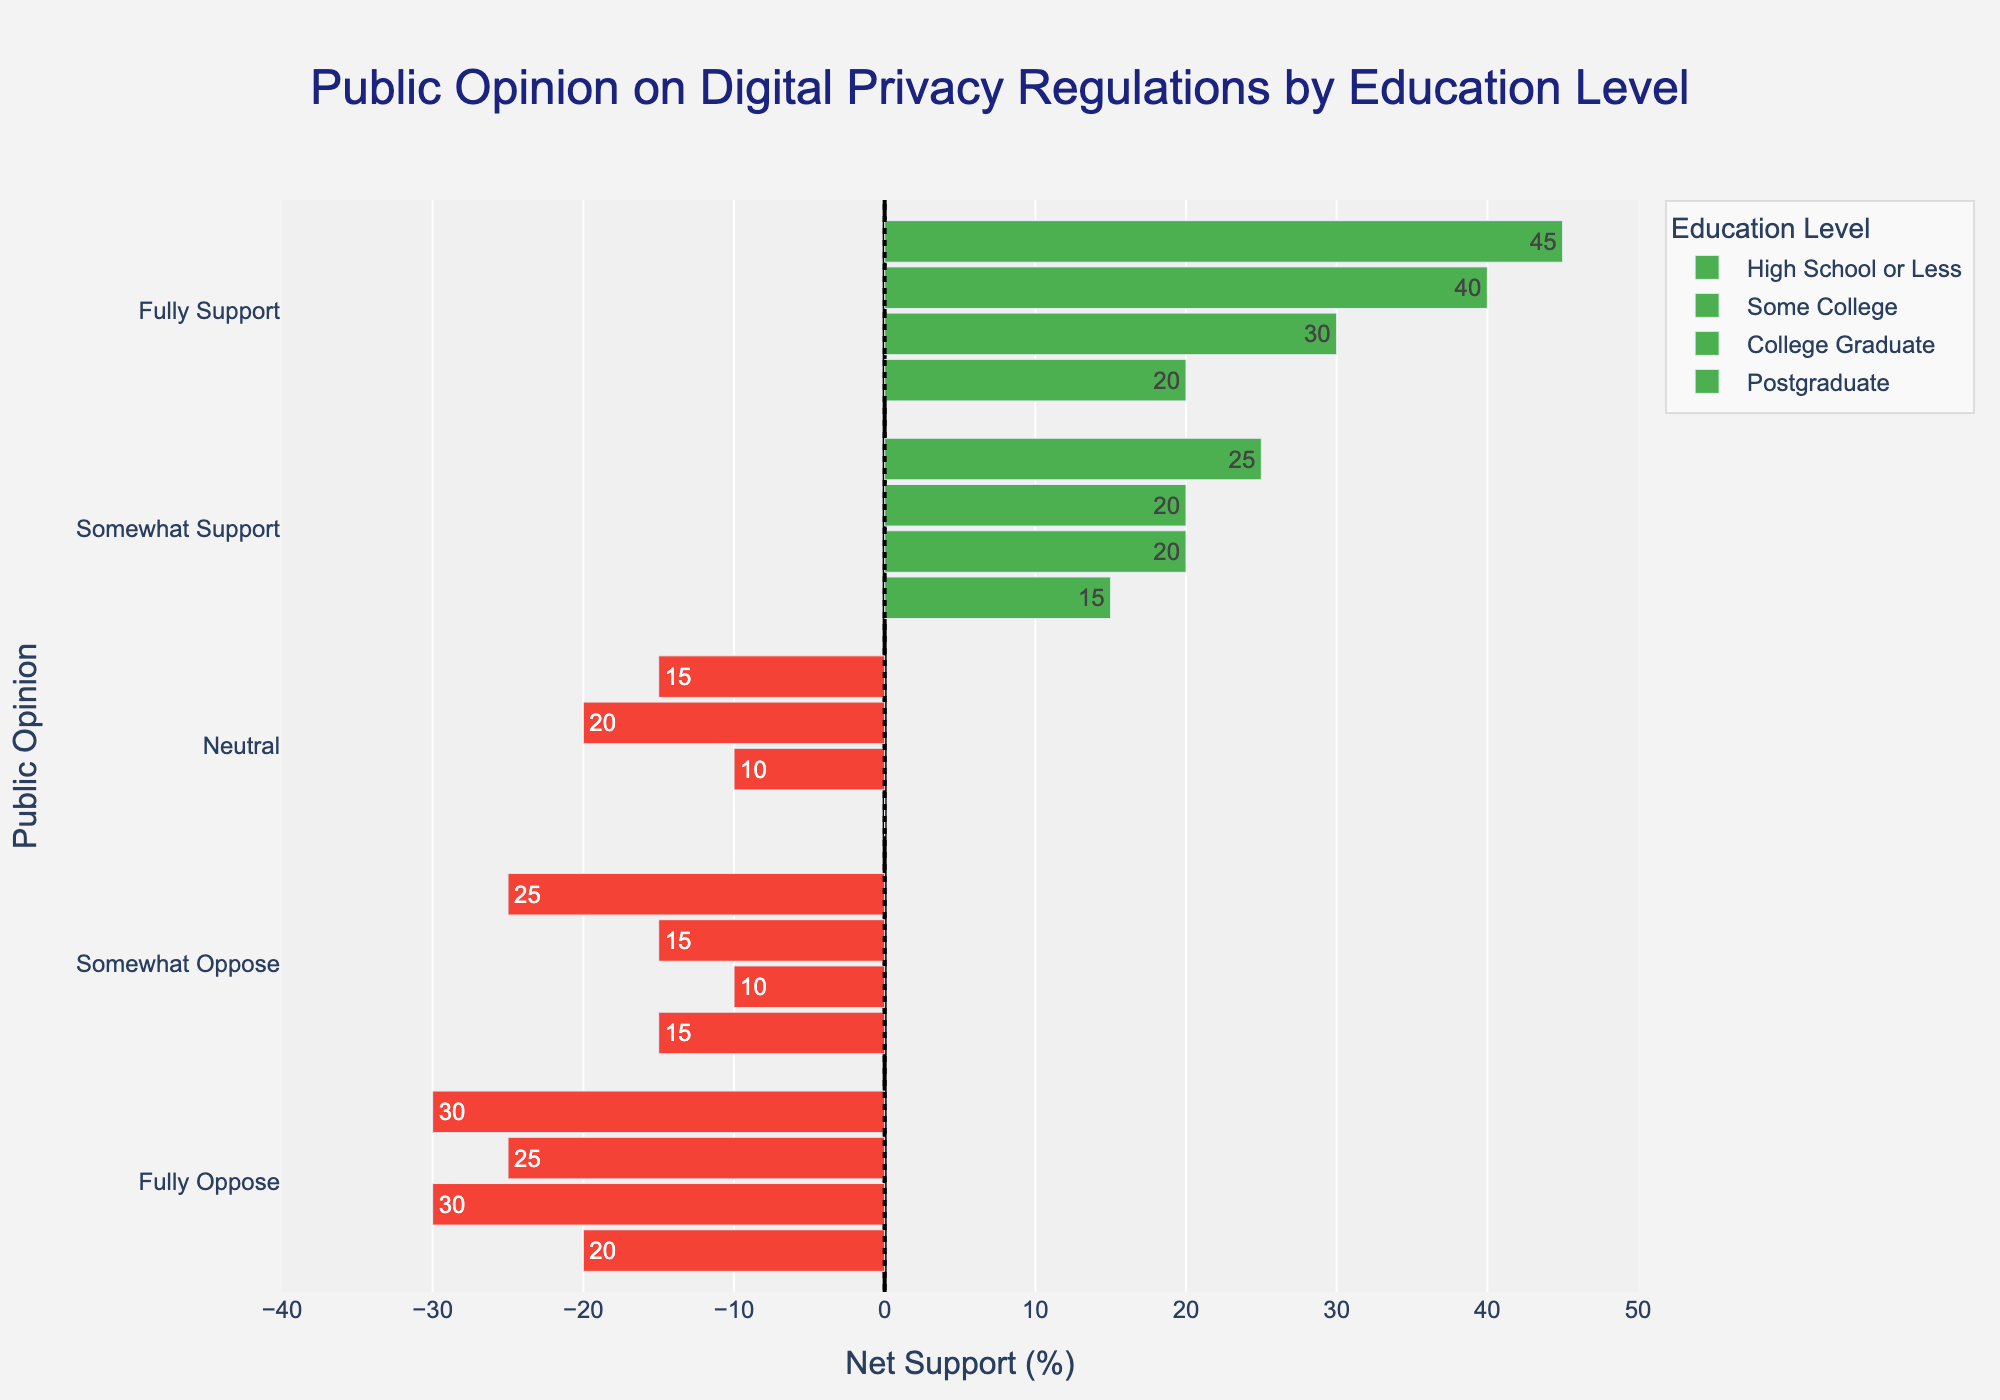What's the education level with the highest net support for fully supporting digital privacy regulations? Look for the bar with the highest positive net support in the 'Fully Support' category. The 'Postgraduate' group has the highest net support for fully supporting digital privacy regulations.
Answer: Postgraduate How does the net opposition compare between 'College Graduate' and 'Some College' for the 'Neutral' opinion? Compare the net support (or opposition) values for 'Neutral' in both 'College Graduate' and 'Some College'. 'College Graduate' has a net support of -20 (10% - 30%) and 'Some College' has a net support of -10 (15% - 25%).
Answer: 'College Graduate' has a higher net opposition In which education category is the support for "Fully Oppose" most positive? Inspect all categories in the 'Fully Oppose' category to see which one has the least negative value (most positive). The "Postgraduate" category has a net support of -30%, which is more positive compared to other categories.
Answer: Postgraduate Compare the net support for "Somewhat Support" between 'High School or Less' and 'College Graduate'. Calculate the net support for "Somewhat Support" in both 'High School or Less' and 'College Graduate'. 'High School or Less' has a net support of 15% (25% - 10%) and 'College Graduate' has a net support of 20% (30% - 10%). 'College Graduate' has a higher net support.
Answer: College Graduate What is the sum of the net supports for "Somewhat Oppose" for both 'High School or Less' and 'Postgraduate'? Calculate the net supports separately, then sum them up. -15% (10-25) for 'High School or Less' and -25% (5-30) for 'Postgraduate'. The sum is -15% + -25% = -40%.
Answer: -40% 